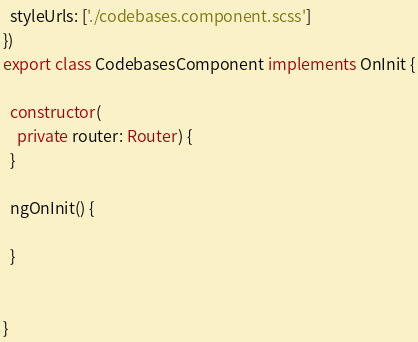<code> <loc_0><loc_0><loc_500><loc_500><_TypeScript_>  styleUrls: ['./codebases.component.scss']
})
export class CodebasesComponent implements OnInit {

  constructor(
    private router: Router) {
  }

  ngOnInit() {
    
  }


}
</code> 